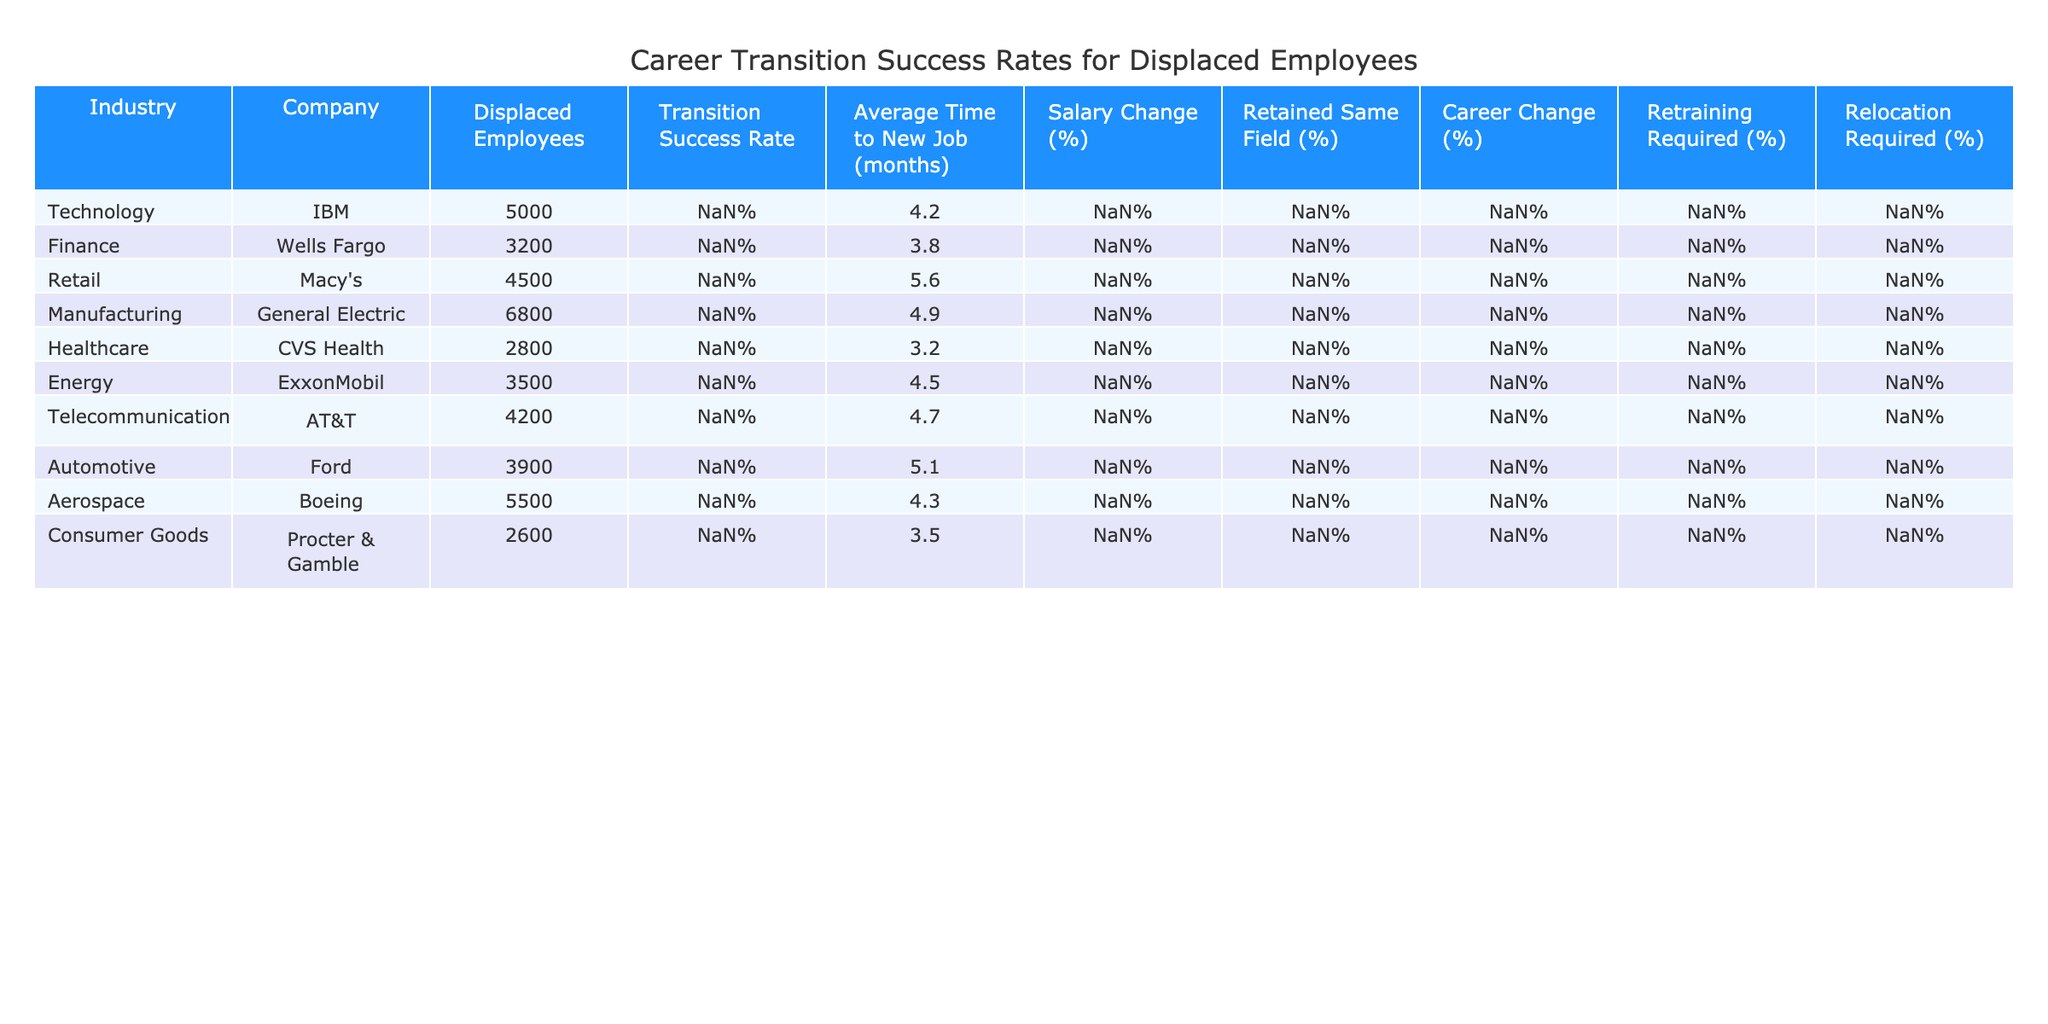What is the transition success rate for employees displaced by IBM? The table shows a specific column for "Transition Success Rate," where the row for IBM is indicated. According to that row, the transition success rate is 78%.
Answer: 78% Which industry has the highest transition success rate according to the table? By examining the "Transition Success Rate" column for each industry, CVS Health has the highest rate at 88%.
Answer: Healthcare What is the average time to a new job for displaced employees in the finance sector? Looking at the "Average Time to New Job (months)" column, Wells Fargo, representing the finance sector, has an average time of 3.8 months to find a new job.
Answer: 3.8 months How many industries have a transition success rate above 75%? Counting the number of entries in the "Transition Success Rate" column that are above 75%, I find five industries: Finance (82%), Healthcare (88%), Consumer Goods (84%), IBM (78%), and Boeing (75%).
Answer: 5 Is it true that displaced employees in the retail sector have a lower average salary change than those in the energy sector? Checking the "Salary Change (%)" column, Macy's (Retail) shows -12% and ExxonMobil (Energy) shows -7%. Since -12% is lower than -7%, the statement is true.
Answer: Yes Calculate the average salary change for all industries listed in the table. Summing the salary changes: (-5% - 2% - 12% - 8% + 2% - 7% + -6% - 9% + -4% + 0%) = -57%. There are 10 industries, so the average is -57% / 10 = -5.7%.
Answer: -5.7% What percentage of displaced employees in the automotive sector needed retraining? The "Retraining Required (%)" column shows for Ford (Automotive) that 50% of displaced employees required retraining.
Answer: 50% Which company experienced the longest average time to a new job, and how long was it? By looking at the "Average Time to New Job (months)" column, I see that Macy's has the longest duration at 5.6 months.
Answer: Macy's, 5.6 months Which industry has the highest percentage of employees retaining the same field? Reviewing the "Retained Same Field (%)" column reveals that CVS Health has the highest percentage at 76%.
Answer: Healthcare Do more than half of the employees in the aerospace sector require relocation? The table indicates "Relocation Required (%)" for Boeing as 29%, which is less than half. Therefore, the statement is false.
Answer: No What is the difference in transition success rates between the healthcare and retail sectors? The transition success rate for healthcare (88%) minus the transition success rate for retail (65%) gives a difference of 23%.
Answer: 23% 